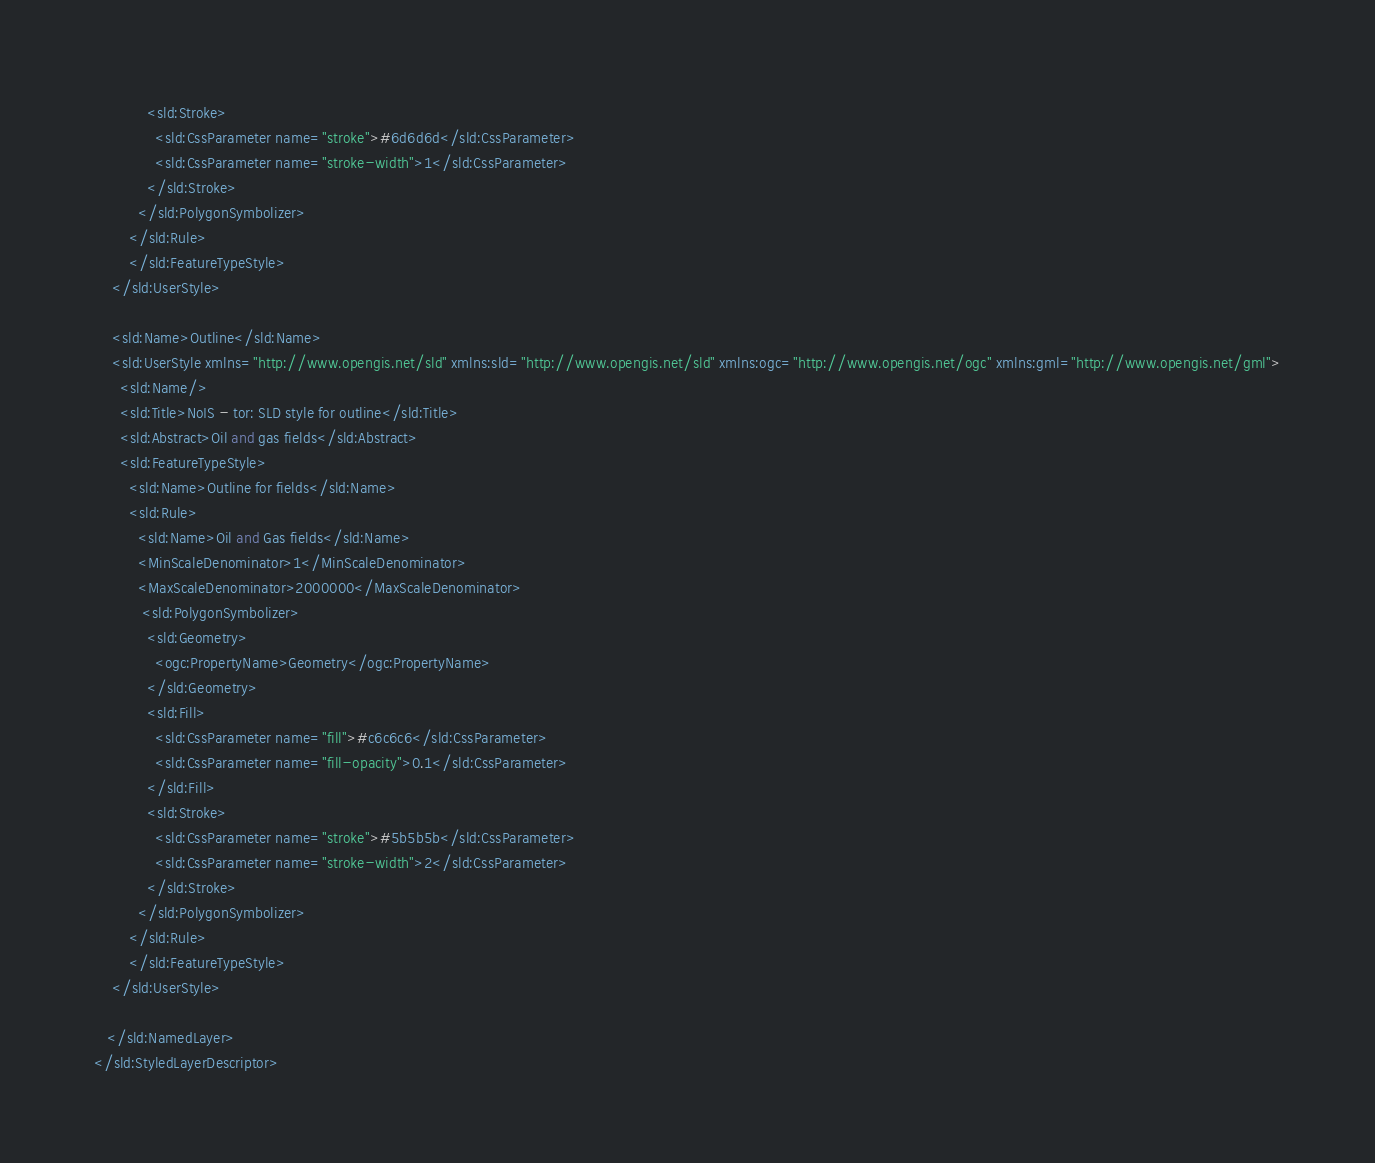<code> <loc_0><loc_0><loc_500><loc_500><_Scheme_>			<sld:Stroke>
			  <sld:CssParameter name="stroke">#6d6d6d</sld:CssParameter>
			  <sld:CssParameter name="stroke-width">1</sld:CssParameter>			  
			</sld:Stroke>
		  </sld:PolygonSymbolizer>
        </sld:Rule>
		</sld:FeatureTypeStyle>
    </sld:UserStyle>
	
    <sld:Name>Outline</sld:Name>
    <sld:UserStyle xmlns="http://www.opengis.net/sld" xmlns:sld="http://www.opengis.net/sld" xmlns:ogc="http://www.opengis.net/ogc" xmlns:gml="http://www.opengis.net/gml">
      <sld:Name/>
      <sld:Title>NoIS - tor: SLD style for outline</sld:Title>
      <sld:Abstract>Oil and gas fields</sld:Abstract>
      <sld:FeatureTypeStyle>
        <sld:Name>Outline for fields</sld:Name>
        <sld:Rule>
          <sld:Name>Oil and Gas fields</sld:Name>
          <MinScaleDenominator>1</MinScaleDenominator>
          <MaxScaleDenominator>2000000</MaxScaleDenominator>
		   <sld:PolygonSymbolizer>
			<sld:Geometry>
			  <ogc:PropertyName>Geometry</ogc:PropertyName>
			</sld:Geometry>
			<sld:Fill>
			  <sld:CssParameter name="fill">#c6c6c6</sld:CssParameter>
			  <sld:CssParameter name="fill-opacity">0.1</sld:CssParameter>
			</sld:Fill>
			<sld:Stroke>
			  <sld:CssParameter name="stroke">#5b5b5b</sld:CssParameter>
			  <sld:CssParameter name="stroke-width">2</sld:CssParameter>			  
			</sld:Stroke>
		  </sld:PolygonSymbolizer>
        </sld:Rule>
		</sld:FeatureTypeStyle>
    </sld:UserStyle>
	
   </sld:NamedLayer>
</sld:StyledLayerDescriptor></code> 